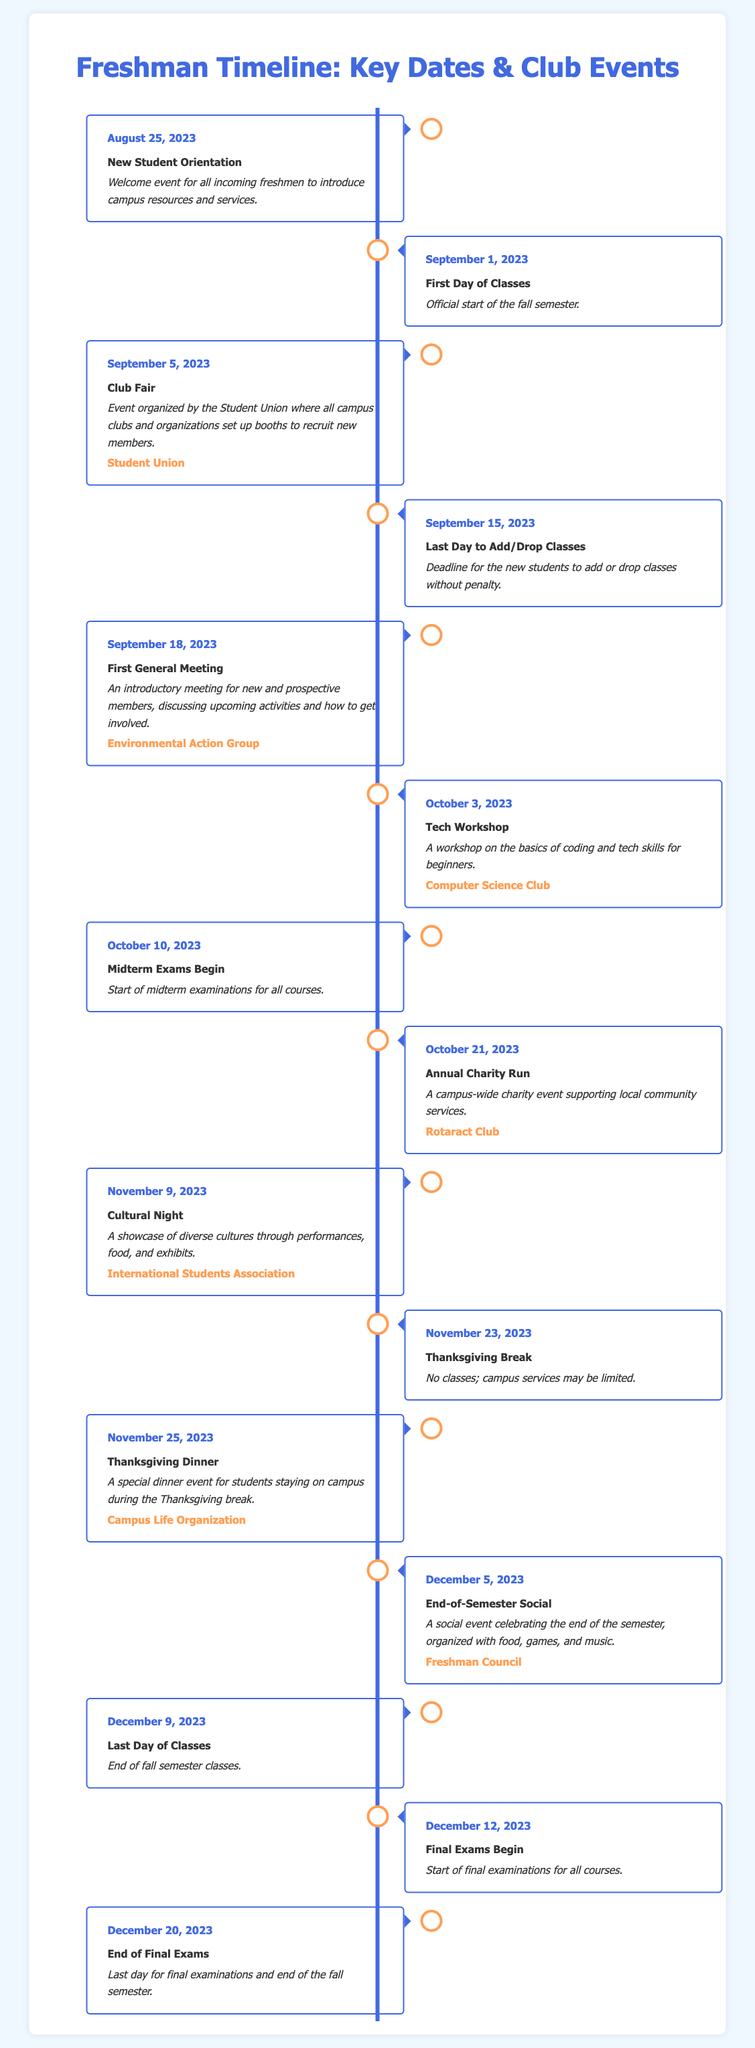What date does New Student Orientation occur? New Student Orientation is listed as occurring on August 25, 2023 in the document.
Answer: August 25, 2023 What is the event on September 5, 2023? The document states that on September 5, 2023, the Club Fair takes place.
Answer: Club Fair When is the last day to add/drop classes? According to the timeline, the last day to add/drop classes is September 15, 2023.
Answer: September 15, 2023 Which club holds the Annual Charity Run? The event for the Annual Charity Run is organized by the Rotaract Club.
Answer: Rotaract Club What is the date of the Thanksgiving Break? The Thanksgiving Break starts on November 23, 2023 as mentioned in the document.
Answer: November 23, 2023 How many days do classes continue after Cultural Night? Cultural Night is on November 9, 2023 and classes end on December 9, 2023, making it 30 days until classes end.
Answer: 30 days Which event occurs before midterm exams? The Tech Workshop occurs on October 3, 2023, which is before midterm exams that begin on October 10, 2023.
Answer: Tech Workshop What type of meeting is held on September 18, 2023? The document indicates that the meeting held on this date is a First General Meeting for new and prospective members.
Answer: First General Meeting What is the last event listed in the timeline? The last event noted in the timeline is the End of Final Exams, taking place on December 20, 2023.
Answer: End of Final Exams 